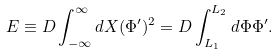Convert formula to latex. <formula><loc_0><loc_0><loc_500><loc_500>E \equiv D \int _ { - \infty } ^ { \infty } d X ( \Phi ^ { \prime } ) ^ { 2 } = D \int _ { L _ { 1 } } ^ { L _ { 2 } } d \Phi \Phi ^ { \prime } .</formula> 